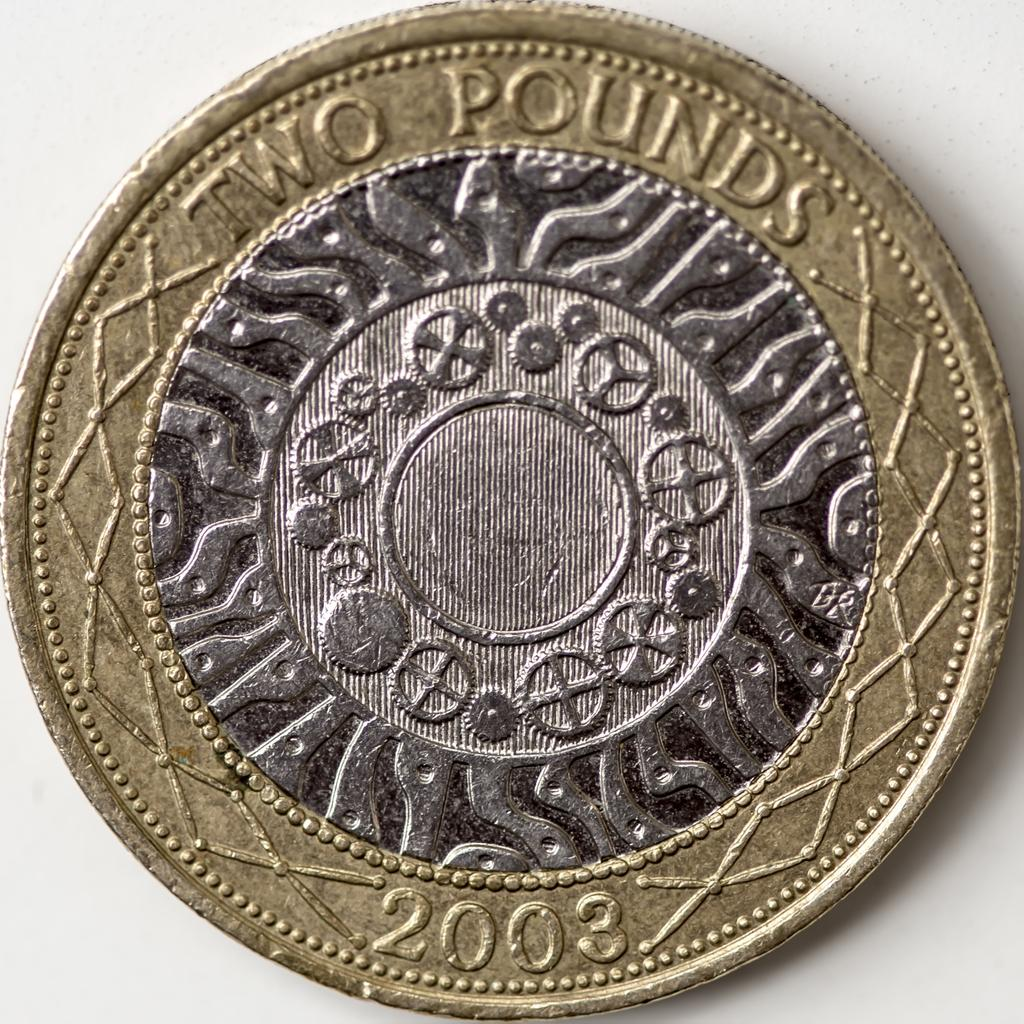<image>
Render a clear and concise summary of the photo. a silver and gold coin for Two Pounds 2003 